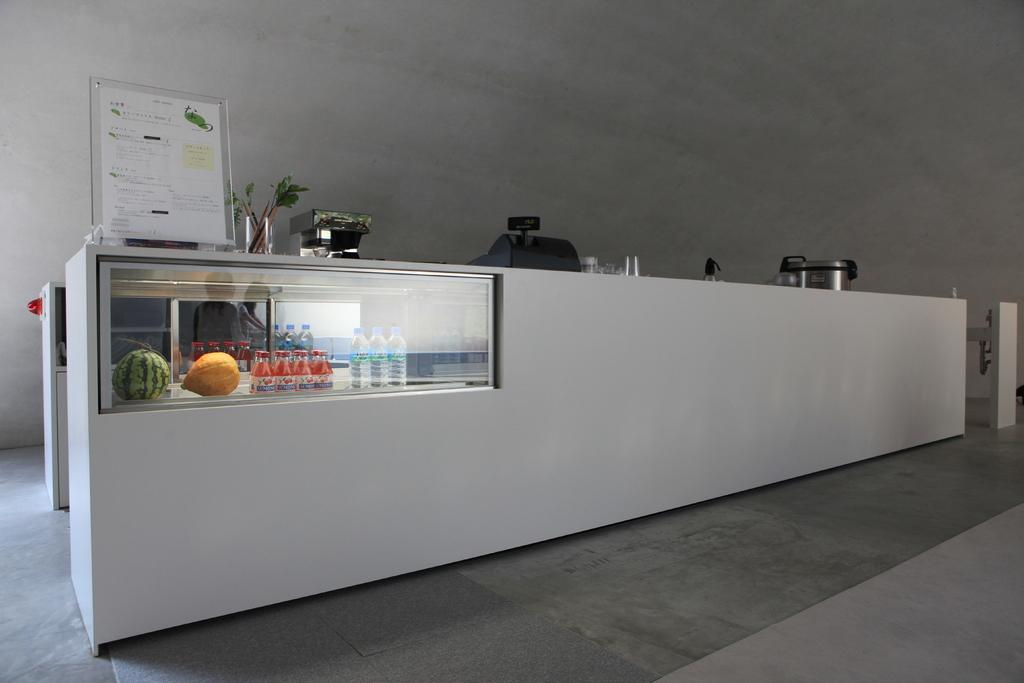What type of surface is visible in the image? There is a floor in the image. What piece of furniture can be seen in the image? There is a table in the image. What type of beverage containers are present in the image? There are water bottles in the image. What type of fruit is visible in the image? There is a watermelon in the image. What type of plant material is present in the image? There are leaves in the image. What type of writing surface is present in the image? There is a glass board in the image. What other objects can be seen in the image? There are other objects in the image, but their specific details are not mentioned in the provided facts. What type of architectural feature is visible in the image? There is a wall in the image. What can be seen in the reflection in the image? There is a reflection of people wearing clothes in the image. How many girls are wearing rings in the image? There are no girls or rings present in the image. What type of wound can be seen on the watermelon in the image? There is no wound visible on the watermelon in the image. 